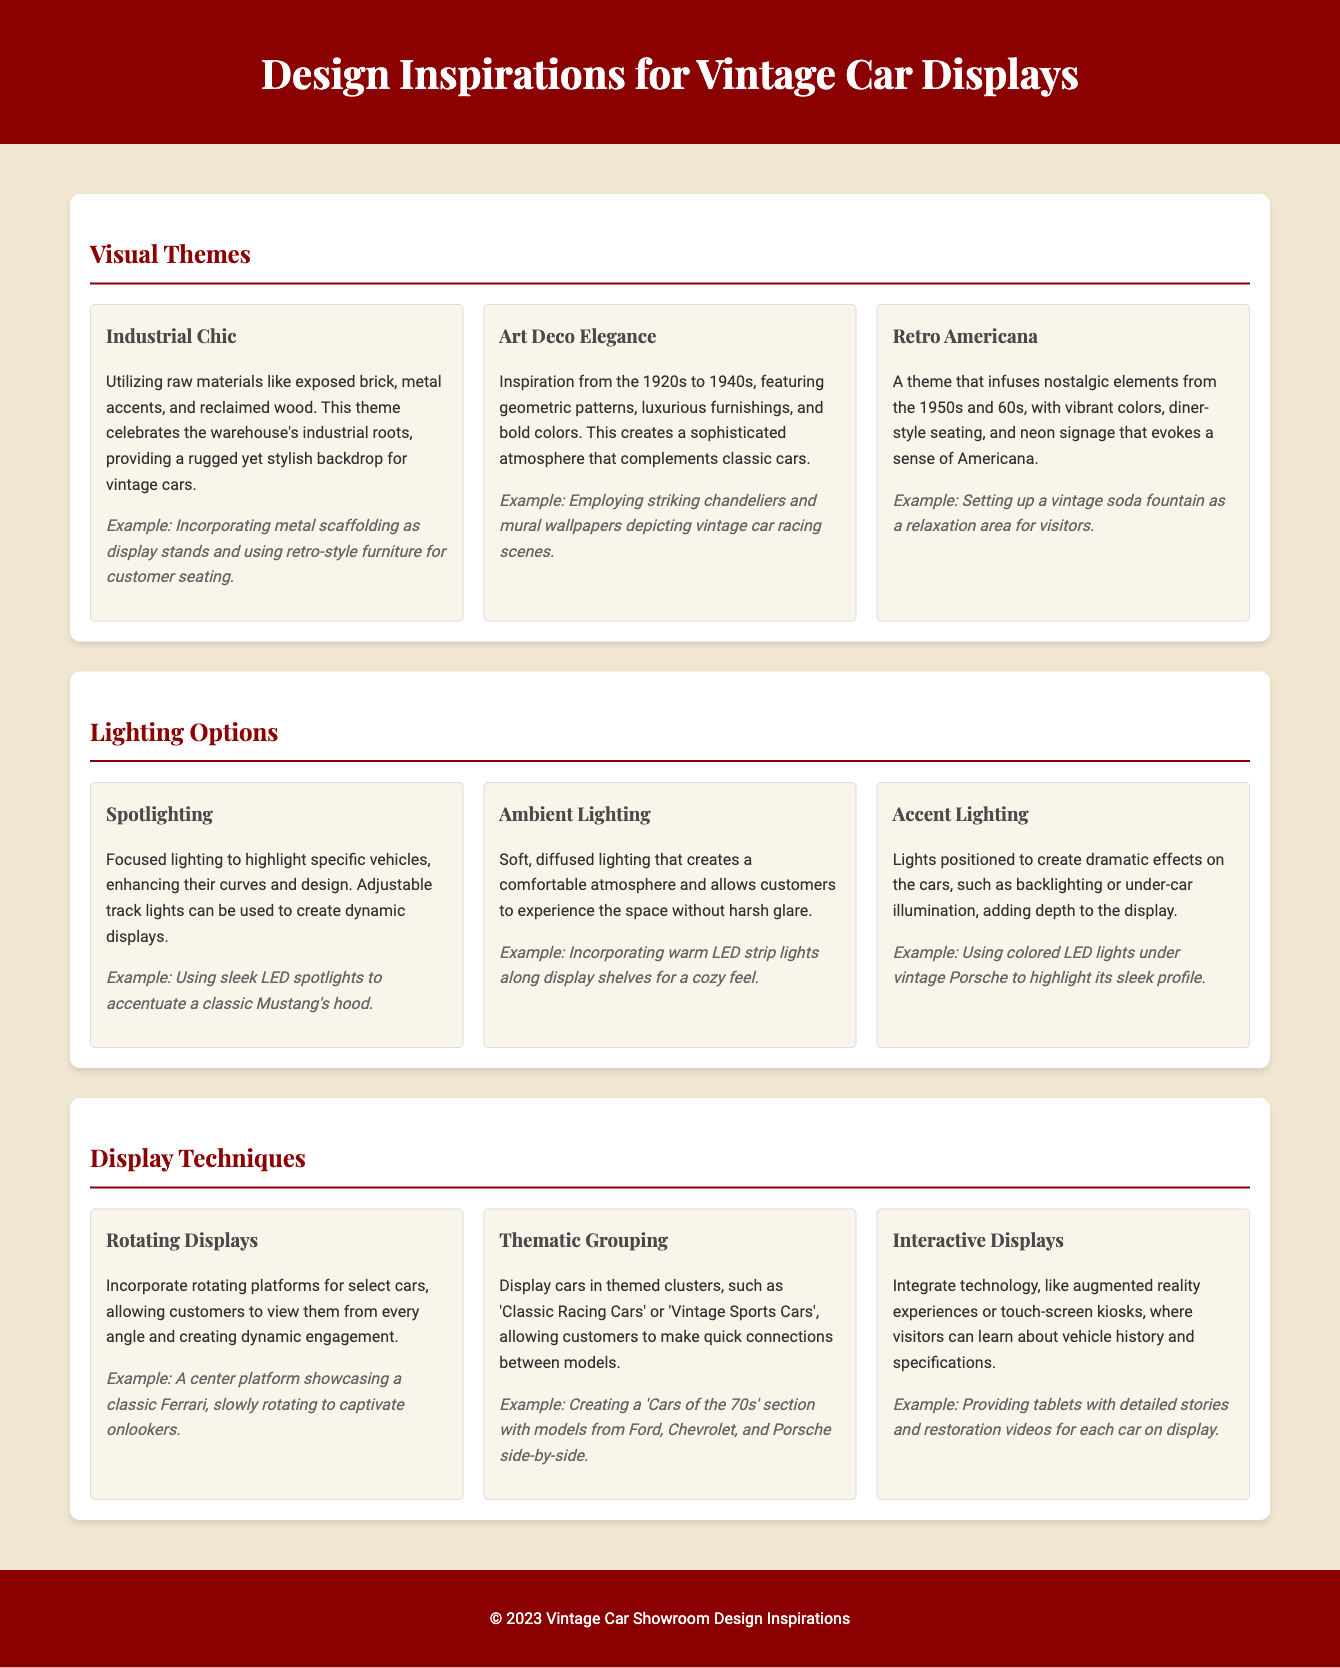What is the first visual theme mentioned? The document lists "Industrial Chic" as the first visual theme under the section for Visual Themes.
Answer: Industrial Chic How many lighting options are described? The document provides details about three different lighting options to enhance the showroom experience.
Answer: Three What style of furnishing is suggested in the Art Deco theme? The Art Deco section mentions using "luxurious furnishings" as part of its aesthetic appeal.
Answer: Luxurious furnishings What display technique involves using technology for customer interaction? The section under Display Techniques describes "Interactive Displays" as a way to integrate technology for visitor engagement.
Answer: Interactive Displays What type of items are suggested to create a 'Cars of the 70s' section? The thematic grouping display technique mentions including models from Ford, Chevrolet, and Porsche as part of this section.
Answer: Ford, Chevrolet, and Porsche Which lighting option is designed for highlighting specific vehicles? Spotlighting is identified in the Lighting Options section as the option meant for emphasizing particular cars.
Answer: Spotlighting What is a key element of the Retro Americana theme? The Retro Americana theme incorporates diner-style seating as a nostalgic element from the 1950s and 60s.
Answer: Diner-style seating 